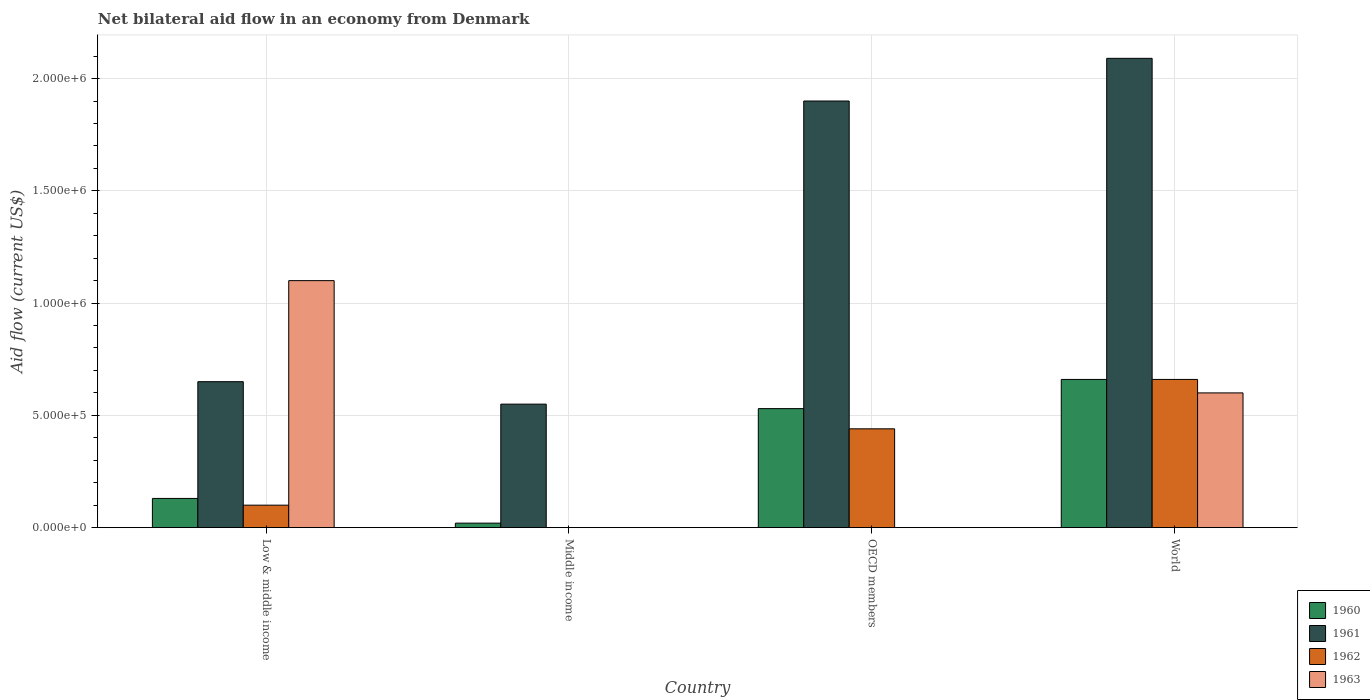How many groups of bars are there?
Provide a succinct answer. 4. Are the number of bars per tick equal to the number of legend labels?
Your response must be concise. No. How many bars are there on the 4th tick from the left?
Offer a very short reply. 4. How many bars are there on the 1st tick from the right?
Ensure brevity in your answer.  4. What is the label of the 3rd group of bars from the left?
Keep it short and to the point. OECD members. What is the net bilateral aid flow in 1960 in Low & middle income?
Keep it short and to the point. 1.30e+05. Across all countries, what is the maximum net bilateral aid flow in 1962?
Provide a succinct answer. 6.60e+05. In which country was the net bilateral aid flow in 1963 maximum?
Your answer should be very brief. Low & middle income. What is the total net bilateral aid flow in 1962 in the graph?
Offer a very short reply. 1.20e+06. What is the difference between the net bilateral aid flow in 1962 in Low & middle income and that in World?
Provide a succinct answer. -5.60e+05. What is the difference between the net bilateral aid flow in 1961 in Low & middle income and the net bilateral aid flow in 1962 in Middle income?
Ensure brevity in your answer.  6.50e+05. What is the average net bilateral aid flow in 1961 per country?
Offer a very short reply. 1.30e+06. In how many countries, is the net bilateral aid flow in 1962 greater than 1300000 US$?
Offer a terse response. 0. What is the ratio of the net bilateral aid flow in 1961 in OECD members to that in World?
Your answer should be compact. 0.91. What is the difference between the highest and the second highest net bilateral aid flow in 1961?
Your answer should be very brief. 1.44e+06. What is the difference between the highest and the lowest net bilateral aid flow in 1963?
Your answer should be very brief. 1.10e+06. In how many countries, is the net bilateral aid flow in 1960 greater than the average net bilateral aid flow in 1960 taken over all countries?
Make the answer very short. 2. Is the sum of the net bilateral aid flow in 1961 in Low & middle income and OECD members greater than the maximum net bilateral aid flow in 1963 across all countries?
Give a very brief answer. Yes. How many bars are there?
Ensure brevity in your answer.  13. What is the difference between two consecutive major ticks on the Y-axis?
Ensure brevity in your answer.  5.00e+05. Where does the legend appear in the graph?
Your answer should be very brief. Bottom right. How many legend labels are there?
Ensure brevity in your answer.  4. How are the legend labels stacked?
Provide a short and direct response. Vertical. What is the title of the graph?
Offer a very short reply. Net bilateral aid flow in an economy from Denmark. Does "1977" appear as one of the legend labels in the graph?
Provide a short and direct response. No. What is the label or title of the X-axis?
Ensure brevity in your answer.  Country. What is the label or title of the Y-axis?
Your answer should be very brief. Aid flow (current US$). What is the Aid flow (current US$) in 1961 in Low & middle income?
Provide a succinct answer. 6.50e+05. What is the Aid flow (current US$) in 1963 in Low & middle income?
Provide a succinct answer. 1.10e+06. What is the Aid flow (current US$) of 1962 in Middle income?
Your response must be concise. 0. What is the Aid flow (current US$) of 1960 in OECD members?
Ensure brevity in your answer.  5.30e+05. What is the Aid flow (current US$) of 1961 in OECD members?
Make the answer very short. 1.90e+06. What is the Aid flow (current US$) in 1962 in OECD members?
Ensure brevity in your answer.  4.40e+05. What is the Aid flow (current US$) of 1963 in OECD members?
Provide a short and direct response. 0. What is the Aid flow (current US$) of 1960 in World?
Provide a succinct answer. 6.60e+05. What is the Aid flow (current US$) in 1961 in World?
Keep it short and to the point. 2.09e+06. What is the Aid flow (current US$) in 1962 in World?
Your response must be concise. 6.60e+05. Across all countries, what is the maximum Aid flow (current US$) in 1960?
Your answer should be very brief. 6.60e+05. Across all countries, what is the maximum Aid flow (current US$) of 1961?
Your answer should be compact. 2.09e+06. Across all countries, what is the maximum Aid flow (current US$) of 1962?
Offer a very short reply. 6.60e+05. Across all countries, what is the maximum Aid flow (current US$) in 1963?
Provide a succinct answer. 1.10e+06. Across all countries, what is the minimum Aid flow (current US$) of 1960?
Keep it short and to the point. 2.00e+04. Across all countries, what is the minimum Aid flow (current US$) of 1961?
Offer a very short reply. 5.50e+05. What is the total Aid flow (current US$) of 1960 in the graph?
Provide a succinct answer. 1.34e+06. What is the total Aid flow (current US$) in 1961 in the graph?
Provide a short and direct response. 5.19e+06. What is the total Aid flow (current US$) in 1962 in the graph?
Your answer should be very brief. 1.20e+06. What is the total Aid flow (current US$) in 1963 in the graph?
Ensure brevity in your answer.  1.70e+06. What is the difference between the Aid flow (current US$) of 1960 in Low & middle income and that in Middle income?
Provide a short and direct response. 1.10e+05. What is the difference between the Aid flow (current US$) in 1960 in Low & middle income and that in OECD members?
Your answer should be very brief. -4.00e+05. What is the difference between the Aid flow (current US$) in 1961 in Low & middle income and that in OECD members?
Offer a very short reply. -1.25e+06. What is the difference between the Aid flow (current US$) in 1960 in Low & middle income and that in World?
Your answer should be compact. -5.30e+05. What is the difference between the Aid flow (current US$) of 1961 in Low & middle income and that in World?
Your answer should be very brief. -1.44e+06. What is the difference between the Aid flow (current US$) of 1962 in Low & middle income and that in World?
Your answer should be very brief. -5.60e+05. What is the difference between the Aid flow (current US$) in 1960 in Middle income and that in OECD members?
Make the answer very short. -5.10e+05. What is the difference between the Aid flow (current US$) of 1961 in Middle income and that in OECD members?
Provide a succinct answer. -1.35e+06. What is the difference between the Aid flow (current US$) of 1960 in Middle income and that in World?
Keep it short and to the point. -6.40e+05. What is the difference between the Aid flow (current US$) in 1961 in Middle income and that in World?
Your answer should be compact. -1.54e+06. What is the difference between the Aid flow (current US$) of 1962 in OECD members and that in World?
Offer a terse response. -2.20e+05. What is the difference between the Aid flow (current US$) of 1960 in Low & middle income and the Aid flow (current US$) of 1961 in Middle income?
Offer a very short reply. -4.20e+05. What is the difference between the Aid flow (current US$) of 1960 in Low & middle income and the Aid flow (current US$) of 1961 in OECD members?
Provide a short and direct response. -1.77e+06. What is the difference between the Aid flow (current US$) in 1960 in Low & middle income and the Aid flow (current US$) in 1962 in OECD members?
Your answer should be compact. -3.10e+05. What is the difference between the Aid flow (current US$) in 1961 in Low & middle income and the Aid flow (current US$) in 1962 in OECD members?
Give a very brief answer. 2.10e+05. What is the difference between the Aid flow (current US$) of 1960 in Low & middle income and the Aid flow (current US$) of 1961 in World?
Offer a very short reply. -1.96e+06. What is the difference between the Aid flow (current US$) of 1960 in Low & middle income and the Aid flow (current US$) of 1962 in World?
Offer a terse response. -5.30e+05. What is the difference between the Aid flow (current US$) of 1960 in Low & middle income and the Aid flow (current US$) of 1963 in World?
Your answer should be compact. -4.70e+05. What is the difference between the Aid flow (current US$) in 1961 in Low & middle income and the Aid flow (current US$) in 1962 in World?
Give a very brief answer. -10000. What is the difference between the Aid flow (current US$) in 1962 in Low & middle income and the Aid flow (current US$) in 1963 in World?
Ensure brevity in your answer.  -5.00e+05. What is the difference between the Aid flow (current US$) of 1960 in Middle income and the Aid flow (current US$) of 1961 in OECD members?
Make the answer very short. -1.88e+06. What is the difference between the Aid flow (current US$) of 1960 in Middle income and the Aid flow (current US$) of 1962 in OECD members?
Ensure brevity in your answer.  -4.20e+05. What is the difference between the Aid flow (current US$) of 1961 in Middle income and the Aid flow (current US$) of 1962 in OECD members?
Give a very brief answer. 1.10e+05. What is the difference between the Aid flow (current US$) of 1960 in Middle income and the Aid flow (current US$) of 1961 in World?
Keep it short and to the point. -2.07e+06. What is the difference between the Aid flow (current US$) in 1960 in Middle income and the Aid flow (current US$) in 1962 in World?
Your answer should be very brief. -6.40e+05. What is the difference between the Aid flow (current US$) in 1960 in Middle income and the Aid flow (current US$) in 1963 in World?
Provide a succinct answer. -5.80e+05. What is the difference between the Aid flow (current US$) of 1961 in Middle income and the Aid flow (current US$) of 1962 in World?
Provide a short and direct response. -1.10e+05. What is the difference between the Aid flow (current US$) of 1961 in Middle income and the Aid flow (current US$) of 1963 in World?
Provide a succinct answer. -5.00e+04. What is the difference between the Aid flow (current US$) in 1960 in OECD members and the Aid flow (current US$) in 1961 in World?
Keep it short and to the point. -1.56e+06. What is the difference between the Aid flow (current US$) of 1960 in OECD members and the Aid flow (current US$) of 1962 in World?
Keep it short and to the point. -1.30e+05. What is the difference between the Aid flow (current US$) of 1961 in OECD members and the Aid flow (current US$) of 1962 in World?
Your answer should be very brief. 1.24e+06. What is the difference between the Aid flow (current US$) of 1961 in OECD members and the Aid flow (current US$) of 1963 in World?
Your response must be concise. 1.30e+06. What is the average Aid flow (current US$) of 1960 per country?
Keep it short and to the point. 3.35e+05. What is the average Aid flow (current US$) in 1961 per country?
Give a very brief answer. 1.30e+06. What is the average Aid flow (current US$) in 1963 per country?
Keep it short and to the point. 4.25e+05. What is the difference between the Aid flow (current US$) in 1960 and Aid flow (current US$) in 1961 in Low & middle income?
Offer a terse response. -5.20e+05. What is the difference between the Aid flow (current US$) in 1960 and Aid flow (current US$) in 1962 in Low & middle income?
Offer a terse response. 3.00e+04. What is the difference between the Aid flow (current US$) in 1960 and Aid flow (current US$) in 1963 in Low & middle income?
Your answer should be compact. -9.70e+05. What is the difference between the Aid flow (current US$) in 1961 and Aid flow (current US$) in 1962 in Low & middle income?
Offer a terse response. 5.50e+05. What is the difference between the Aid flow (current US$) in 1961 and Aid flow (current US$) in 1963 in Low & middle income?
Your answer should be very brief. -4.50e+05. What is the difference between the Aid flow (current US$) of 1960 and Aid flow (current US$) of 1961 in Middle income?
Ensure brevity in your answer.  -5.30e+05. What is the difference between the Aid flow (current US$) in 1960 and Aid flow (current US$) in 1961 in OECD members?
Your answer should be compact. -1.37e+06. What is the difference between the Aid flow (current US$) in 1961 and Aid flow (current US$) in 1962 in OECD members?
Ensure brevity in your answer.  1.46e+06. What is the difference between the Aid flow (current US$) in 1960 and Aid flow (current US$) in 1961 in World?
Offer a terse response. -1.43e+06. What is the difference between the Aid flow (current US$) in 1960 and Aid flow (current US$) in 1963 in World?
Make the answer very short. 6.00e+04. What is the difference between the Aid flow (current US$) in 1961 and Aid flow (current US$) in 1962 in World?
Your answer should be very brief. 1.43e+06. What is the difference between the Aid flow (current US$) in 1961 and Aid flow (current US$) in 1963 in World?
Give a very brief answer. 1.49e+06. What is the ratio of the Aid flow (current US$) in 1961 in Low & middle income to that in Middle income?
Keep it short and to the point. 1.18. What is the ratio of the Aid flow (current US$) in 1960 in Low & middle income to that in OECD members?
Offer a terse response. 0.25. What is the ratio of the Aid flow (current US$) of 1961 in Low & middle income to that in OECD members?
Ensure brevity in your answer.  0.34. What is the ratio of the Aid flow (current US$) of 1962 in Low & middle income to that in OECD members?
Your response must be concise. 0.23. What is the ratio of the Aid flow (current US$) in 1960 in Low & middle income to that in World?
Offer a very short reply. 0.2. What is the ratio of the Aid flow (current US$) of 1961 in Low & middle income to that in World?
Make the answer very short. 0.31. What is the ratio of the Aid flow (current US$) of 1962 in Low & middle income to that in World?
Keep it short and to the point. 0.15. What is the ratio of the Aid flow (current US$) in 1963 in Low & middle income to that in World?
Give a very brief answer. 1.83. What is the ratio of the Aid flow (current US$) in 1960 in Middle income to that in OECD members?
Provide a short and direct response. 0.04. What is the ratio of the Aid flow (current US$) of 1961 in Middle income to that in OECD members?
Make the answer very short. 0.29. What is the ratio of the Aid flow (current US$) in 1960 in Middle income to that in World?
Make the answer very short. 0.03. What is the ratio of the Aid flow (current US$) in 1961 in Middle income to that in World?
Provide a short and direct response. 0.26. What is the ratio of the Aid flow (current US$) of 1960 in OECD members to that in World?
Keep it short and to the point. 0.8. What is the ratio of the Aid flow (current US$) of 1962 in OECD members to that in World?
Provide a short and direct response. 0.67. What is the difference between the highest and the second highest Aid flow (current US$) in 1962?
Provide a succinct answer. 2.20e+05. What is the difference between the highest and the lowest Aid flow (current US$) of 1960?
Make the answer very short. 6.40e+05. What is the difference between the highest and the lowest Aid flow (current US$) in 1961?
Your answer should be compact. 1.54e+06. What is the difference between the highest and the lowest Aid flow (current US$) in 1963?
Make the answer very short. 1.10e+06. 